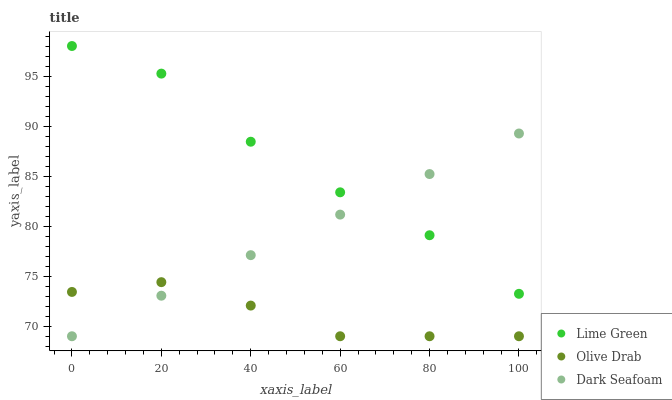Does Olive Drab have the minimum area under the curve?
Answer yes or no. Yes. Does Lime Green have the maximum area under the curve?
Answer yes or no. Yes. Does Lime Green have the minimum area under the curve?
Answer yes or no. No. Does Olive Drab have the maximum area under the curve?
Answer yes or no. No. Is Dark Seafoam the smoothest?
Answer yes or no. Yes. Is Lime Green the roughest?
Answer yes or no. Yes. Is Olive Drab the smoothest?
Answer yes or no. No. Is Olive Drab the roughest?
Answer yes or no. No. Does Dark Seafoam have the lowest value?
Answer yes or no. Yes. Does Lime Green have the lowest value?
Answer yes or no. No. Does Lime Green have the highest value?
Answer yes or no. Yes. Does Olive Drab have the highest value?
Answer yes or no. No. Is Olive Drab less than Lime Green?
Answer yes or no. Yes. Is Lime Green greater than Olive Drab?
Answer yes or no. Yes. Does Dark Seafoam intersect Lime Green?
Answer yes or no. Yes. Is Dark Seafoam less than Lime Green?
Answer yes or no. No. Is Dark Seafoam greater than Lime Green?
Answer yes or no. No. Does Olive Drab intersect Lime Green?
Answer yes or no. No. 